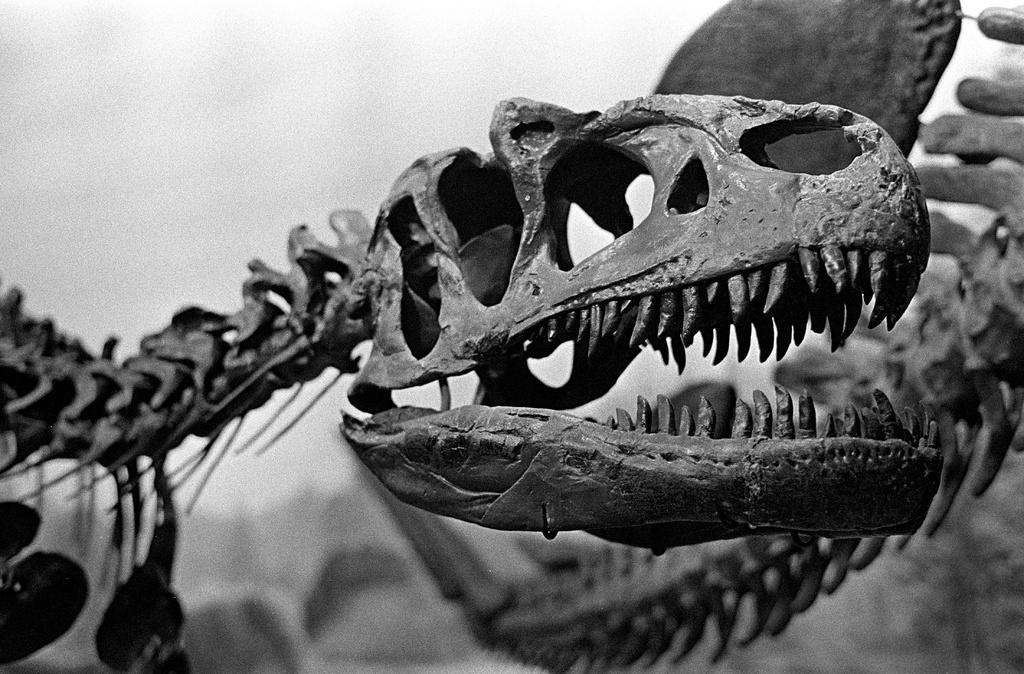What is the color scheme of the image? The image is black and white. What type of objects can be seen in the image? There are skeletons of animals in the image. Can you describe the background of the image? The background of the image is not clear to describe. What attraction can be seen in the background of the image? There is no attraction visible in the background of the image, as it is not clear enough to describe. What story is being told by the skeletons in the image? The image does not convey a specific story; it simply shows skeletons of animals. 